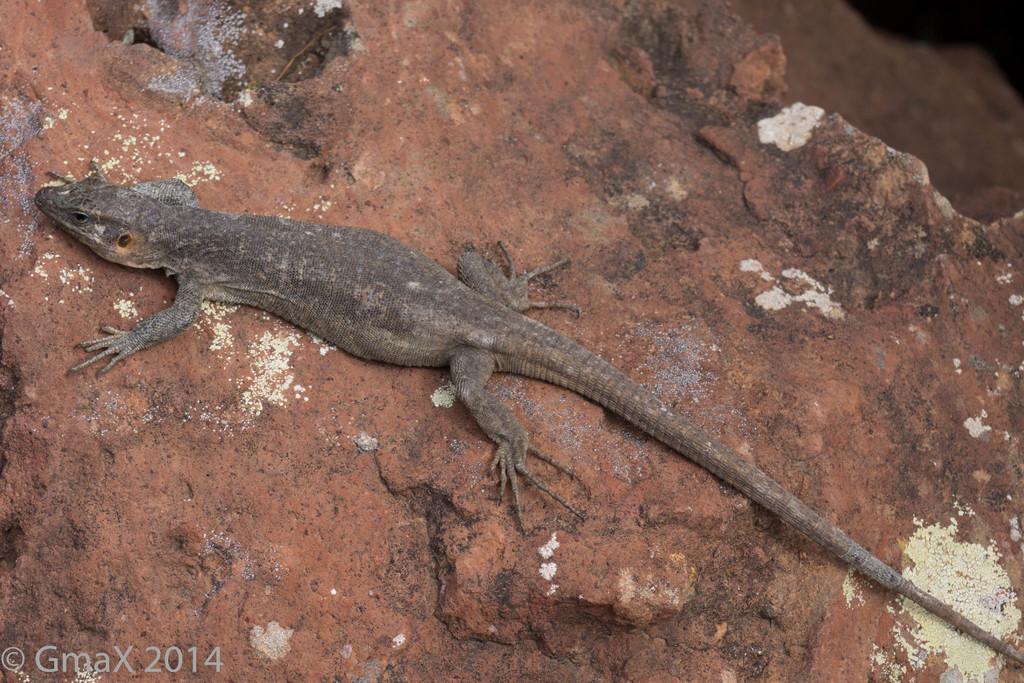Can you describe this image briefly? In this image I can see a lizard which is black and brown in color on the rock which is brown and white in color. 